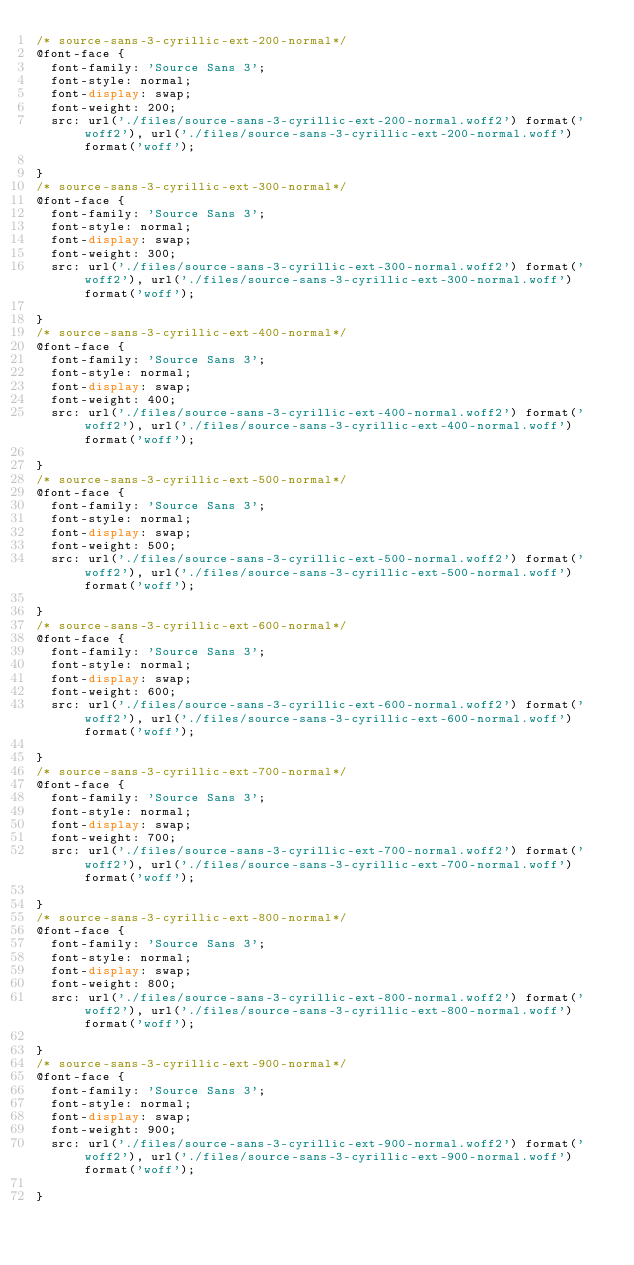Convert code to text. <code><loc_0><loc_0><loc_500><loc_500><_CSS_>/* source-sans-3-cyrillic-ext-200-normal*/
@font-face {
  font-family: 'Source Sans 3';
  font-style: normal;
  font-display: swap;
  font-weight: 200;
  src: url('./files/source-sans-3-cyrillic-ext-200-normal.woff2') format('woff2'), url('./files/source-sans-3-cyrillic-ext-200-normal.woff') format('woff');
  
}
/* source-sans-3-cyrillic-ext-300-normal*/
@font-face {
  font-family: 'Source Sans 3';
  font-style: normal;
  font-display: swap;
  font-weight: 300;
  src: url('./files/source-sans-3-cyrillic-ext-300-normal.woff2') format('woff2'), url('./files/source-sans-3-cyrillic-ext-300-normal.woff') format('woff');
  
}
/* source-sans-3-cyrillic-ext-400-normal*/
@font-face {
  font-family: 'Source Sans 3';
  font-style: normal;
  font-display: swap;
  font-weight: 400;
  src: url('./files/source-sans-3-cyrillic-ext-400-normal.woff2') format('woff2'), url('./files/source-sans-3-cyrillic-ext-400-normal.woff') format('woff');
  
}
/* source-sans-3-cyrillic-ext-500-normal*/
@font-face {
  font-family: 'Source Sans 3';
  font-style: normal;
  font-display: swap;
  font-weight: 500;
  src: url('./files/source-sans-3-cyrillic-ext-500-normal.woff2') format('woff2'), url('./files/source-sans-3-cyrillic-ext-500-normal.woff') format('woff');
  
}
/* source-sans-3-cyrillic-ext-600-normal*/
@font-face {
  font-family: 'Source Sans 3';
  font-style: normal;
  font-display: swap;
  font-weight: 600;
  src: url('./files/source-sans-3-cyrillic-ext-600-normal.woff2') format('woff2'), url('./files/source-sans-3-cyrillic-ext-600-normal.woff') format('woff');
  
}
/* source-sans-3-cyrillic-ext-700-normal*/
@font-face {
  font-family: 'Source Sans 3';
  font-style: normal;
  font-display: swap;
  font-weight: 700;
  src: url('./files/source-sans-3-cyrillic-ext-700-normal.woff2') format('woff2'), url('./files/source-sans-3-cyrillic-ext-700-normal.woff') format('woff');
  
}
/* source-sans-3-cyrillic-ext-800-normal*/
@font-face {
  font-family: 'Source Sans 3';
  font-style: normal;
  font-display: swap;
  font-weight: 800;
  src: url('./files/source-sans-3-cyrillic-ext-800-normal.woff2') format('woff2'), url('./files/source-sans-3-cyrillic-ext-800-normal.woff') format('woff');
  
}
/* source-sans-3-cyrillic-ext-900-normal*/
@font-face {
  font-family: 'Source Sans 3';
  font-style: normal;
  font-display: swap;
  font-weight: 900;
  src: url('./files/source-sans-3-cyrillic-ext-900-normal.woff2') format('woff2'), url('./files/source-sans-3-cyrillic-ext-900-normal.woff') format('woff');
  
}
</code> 